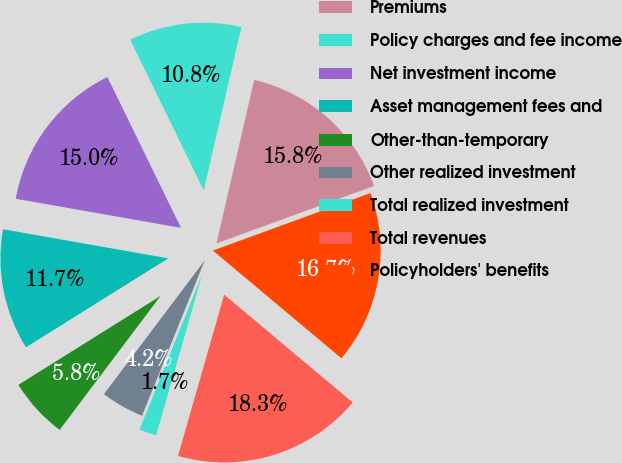Convert chart. <chart><loc_0><loc_0><loc_500><loc_500><pie_chart><fcel>Premiums<fcel>Policy charges and fee income<fcel>Net investment income<fcel>Asset management fees and<fcel>Other-than-temporary<fcel>Other realized investment<fcel>Total realized investment<fcel>Total revenues<fcel>Policyholders' benefits<nl><fcel>15.83%<fcel>10.83%<fcel>15.0%<fcel>11.67%<fcel>5.83%<fcel>4.17%<fcel>1.67%<fcel>18.33%<fcel>16.67%<nl></chart> 